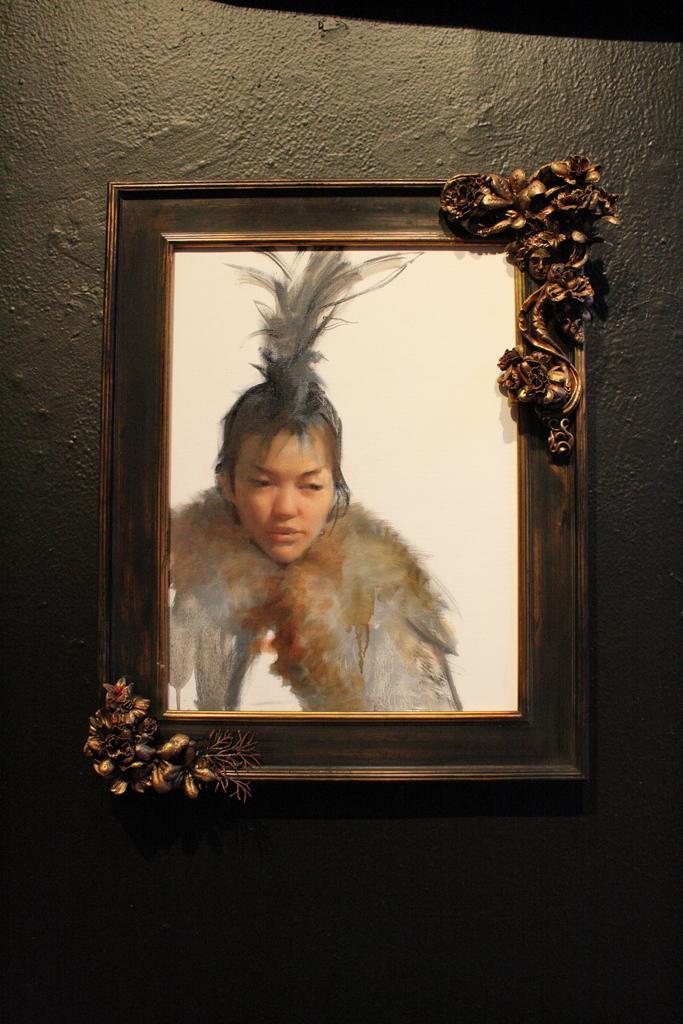Could you give a brief overview of what you see in this image? In this image there is a photo frame on the wall. In the photo there is a girl. 